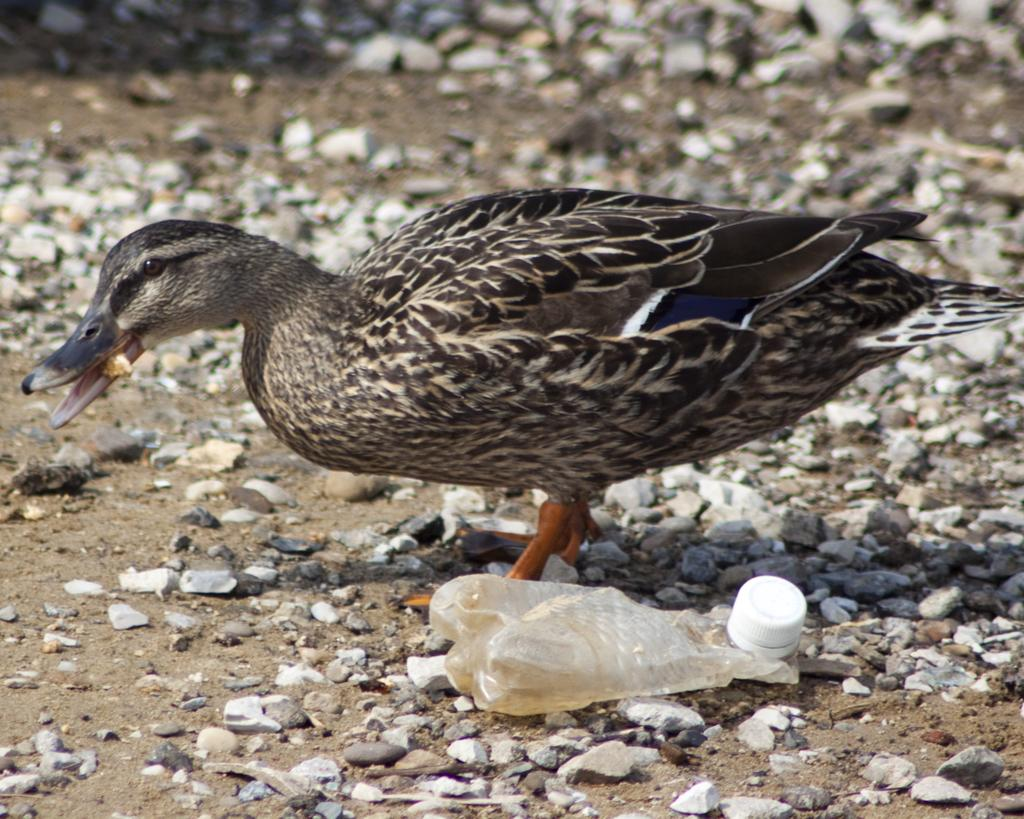What type of animal can be seen in the image? There is a small bird in the image. What is the bird doing in the image? The bird is holding a fish in its mouth. What object is located beside the bird? There is a plastic bottle beside the bird. What can be seen on the ground in the image? There are rocks on the ground in the image. How would you describe the background of the image? The background of the image is blurred. How many ladybugs can be seen crawling on the rocks in the image? There are no ladybugs present in the image; it features a small bird holding a fish, a plastic bottle, and rocks on the ground. 